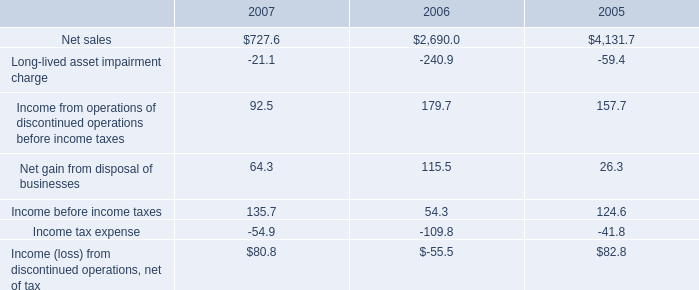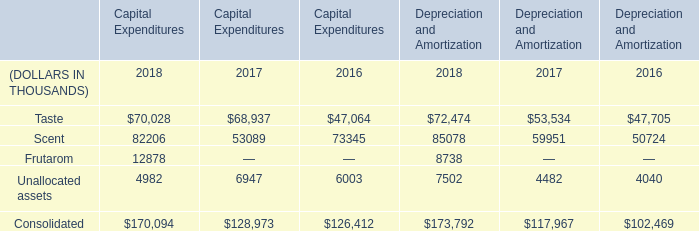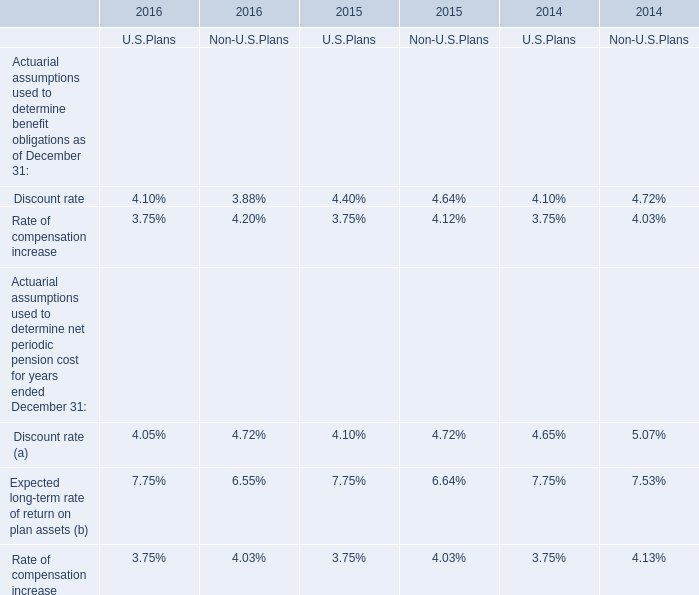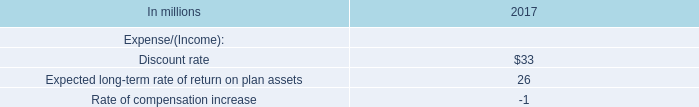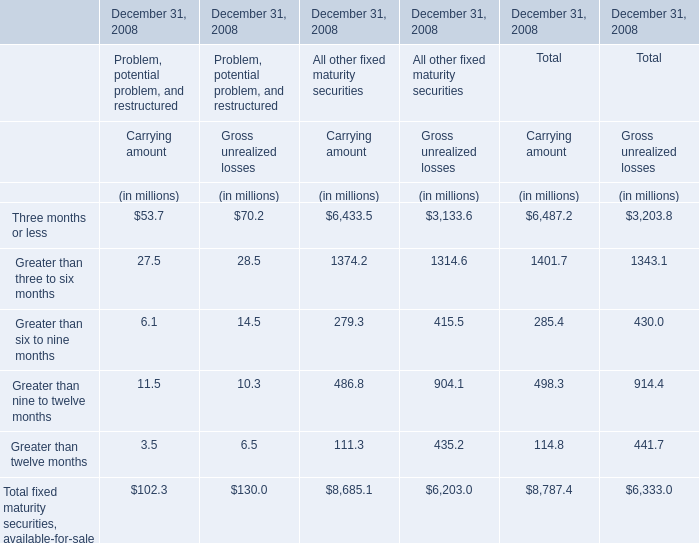What's the sum of Consolidated of Depreciation and Amortization 2018, and Net sales of 2005 ? 
Computations: (173792.0 + 4131.7)
Answer: 177923.7. 